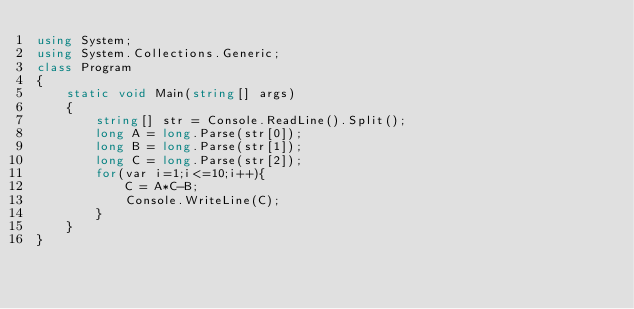Convert code to text. <code><loc_0><loc_0><loc_500><loc_500><_C#_>using System;
using System.Collections.Generic;
class Program
{
	static void Main(string[] args)
	{
		string[] str = Console.ReadLine().Split();
		long A = long.Parse(str[0]);
		long B = long.Parse(str[1]);
		long C = long.Parse(str[2]);
		for(var i=1;i<=10;i++){
			C = A*C-B;
			Console.WriteLine(C);
		}
	}
}</code> 